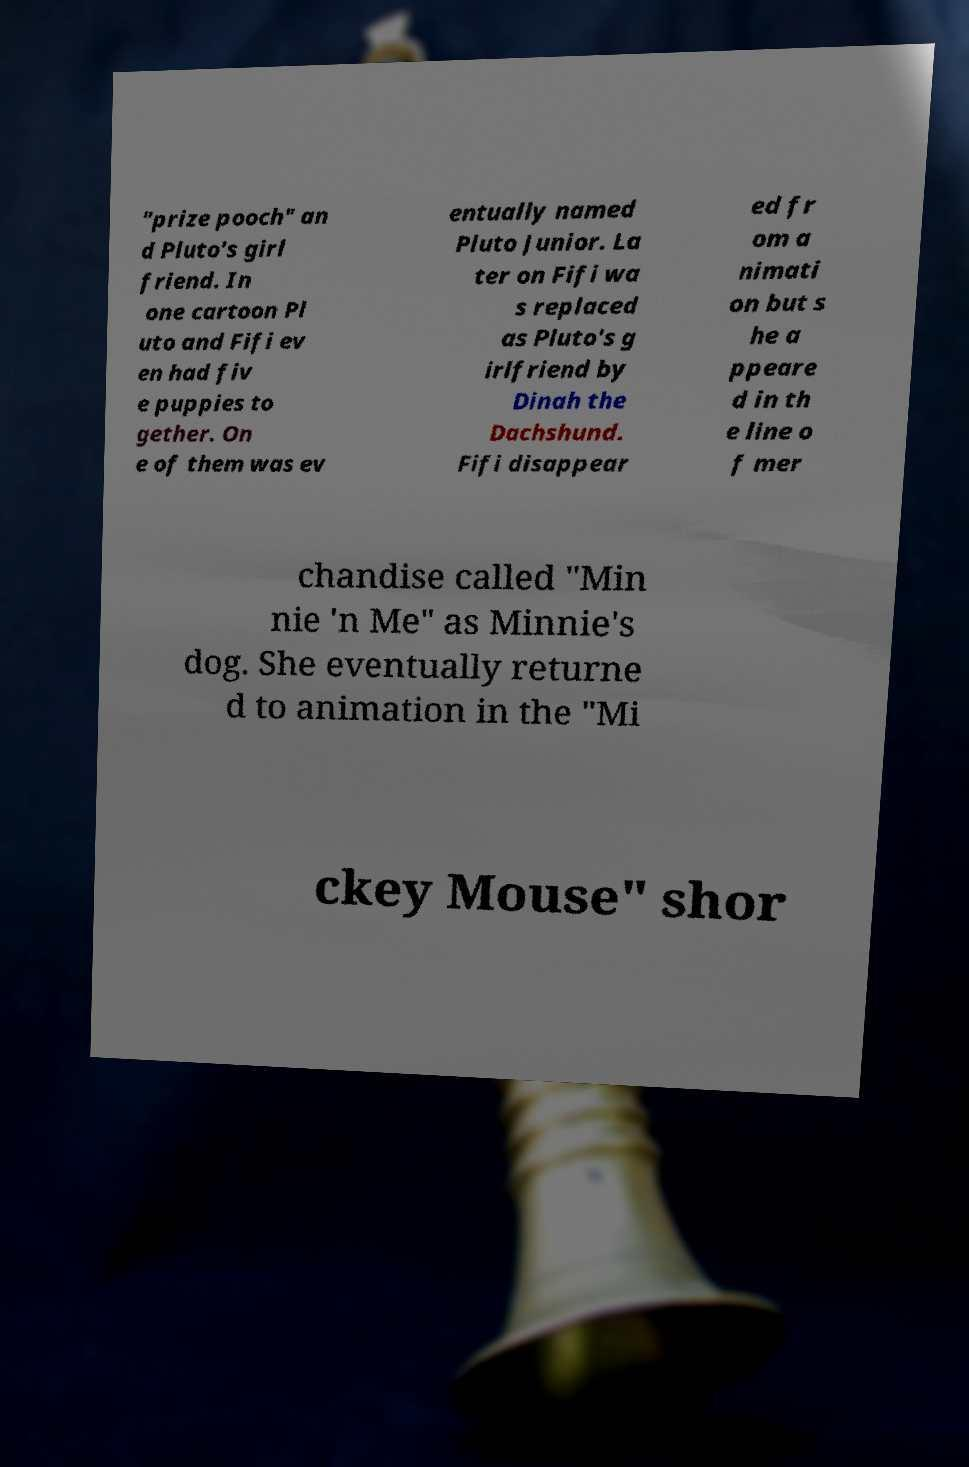For documentation purposes, I need the text within this image transcribed. Could you provide that? "prize pooch" an d Pluto's girl friend. In one cartoon Pl uto and Fifi ev en had fiv e puppies to gether. On e of them was ev entually named Pluto Junior. La ter on Fifi wa s replaced as Pluto's g irlfriend by Dinah the Dachshund. Fifi disappear ed fr om a nimati on but s he a ppeare d in th e line o f mer chandise called "Min nie 'n Me" as Minnie's dog. She eventually returne d to animation in the "Mi ckey Mouse" shor 